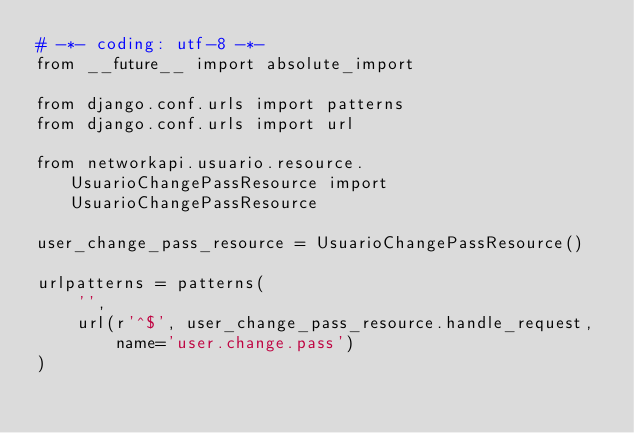<code> <loc_0><loc_0><loc_500><loc_500><_Python_># -*- coding: utf-8 -*-
from __future__ import absolute_import

from django.conf.urls import patterns
from django.conf.urls import url

from networkapi.usuario.resource.UsuarioChangePassResource import UsuarioChangePassResource

user_change_pass_resource = UsuarioChangePassResource()

urlpatterns = patterns(
    '',
    url(r'^$', user_change_pass_resource.handle_request,
        name='user.change.pass')
)
</code> 